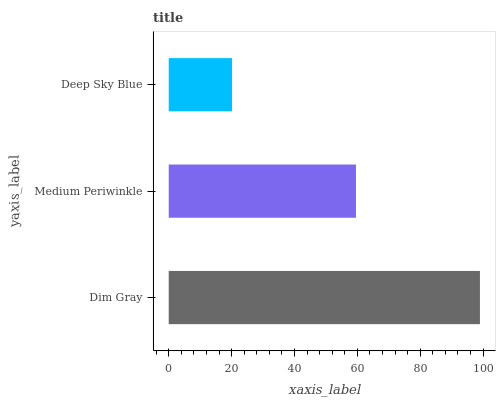Is Deep Sky Blue the minimum?
Answer yes or no. Yes. Is Dim Gray the maximum?
Answer yes or no. Yes. Is Medium Periwinkle the minimum?
Answer yes or no. No. Is Medium Periwinkle the maximum?
Answer yes or no. No. Is Dim Gray greater than Medium Periwinkle?
Answer yes or no. Yes. Is Medium Periwinkle less than Dim Gray?
Answer yes or no. Yes. Is Medium Periwinkle greater than Dim Gray?
Answer yes or no. No. Is Dim Gray less than Medium Periwinkle?
Answer yes or no. No. Is Medium Periwinkle the high median?
Answer yes or no. Yes. Is Medium Periwinkle the low median?
Answer yes or no. Yes. Is Dim Gray the high median?
Answer yes or no. No. Is Deep Sky Blue the low median?
Answer yes or no. No. 